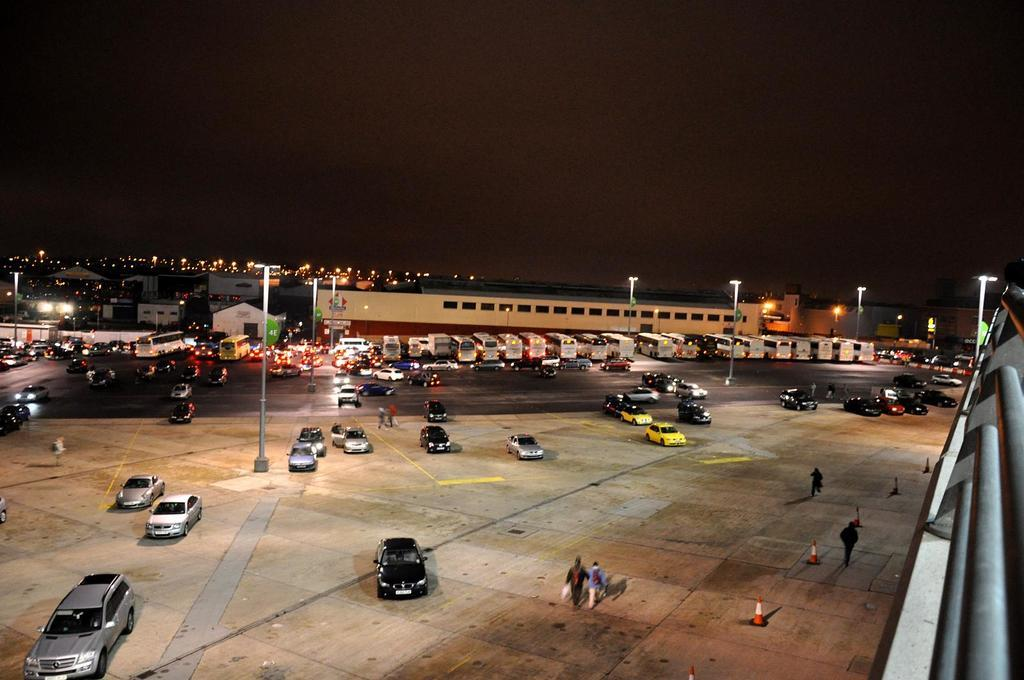What is happening on the road in the image? There are vehicles on the road and people walking on the road in the image. What can be seen in the background of the image? There are buildings, a street light, poles, and the sky visible in the background of the image. What might be used to direct traffic in the image? Traffic cones are present in the image. What type of pets can be seen walking with the people in the image? There are no pets visible in the image; only people and vehicles are present. What time of day is it in the image, given the presence of morning light? The time of day cannot be determined from the image, as there is no mention of morning light or any other indication of the time of day. 